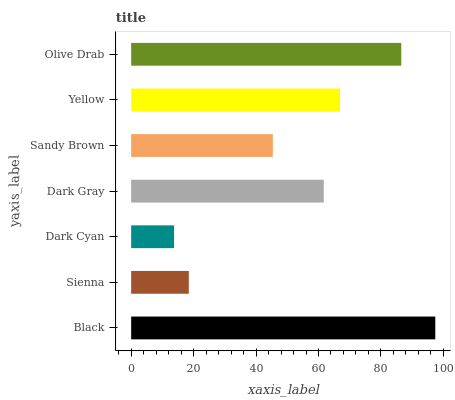Is Dark Cyan the minimum?
Answer yes or no. Yes. Is Black the maximum?
Answer yes or no. Yes. Is Sienna the minimum?
Answer yes or no. No. Is Sienna the maximum?
Answer yes or no. No. Is Black greater than Sienna?
Answer yes or no. Yes. Is Sienna less than Black?
Answer yes or no. Yes. Is Sienna greater than Black?
Answer yes or no. No. Is Black less than Sienna?
Answer yes or no. No. Is Dark Gray the high median?
Answer yes or no. Yes. Is Dark Gray the low median?
Answer yes or no. Yes. Is Sienna the high median?
Answer yes or no. No. Is Yellow the low median?
Answer yes or no. No. 